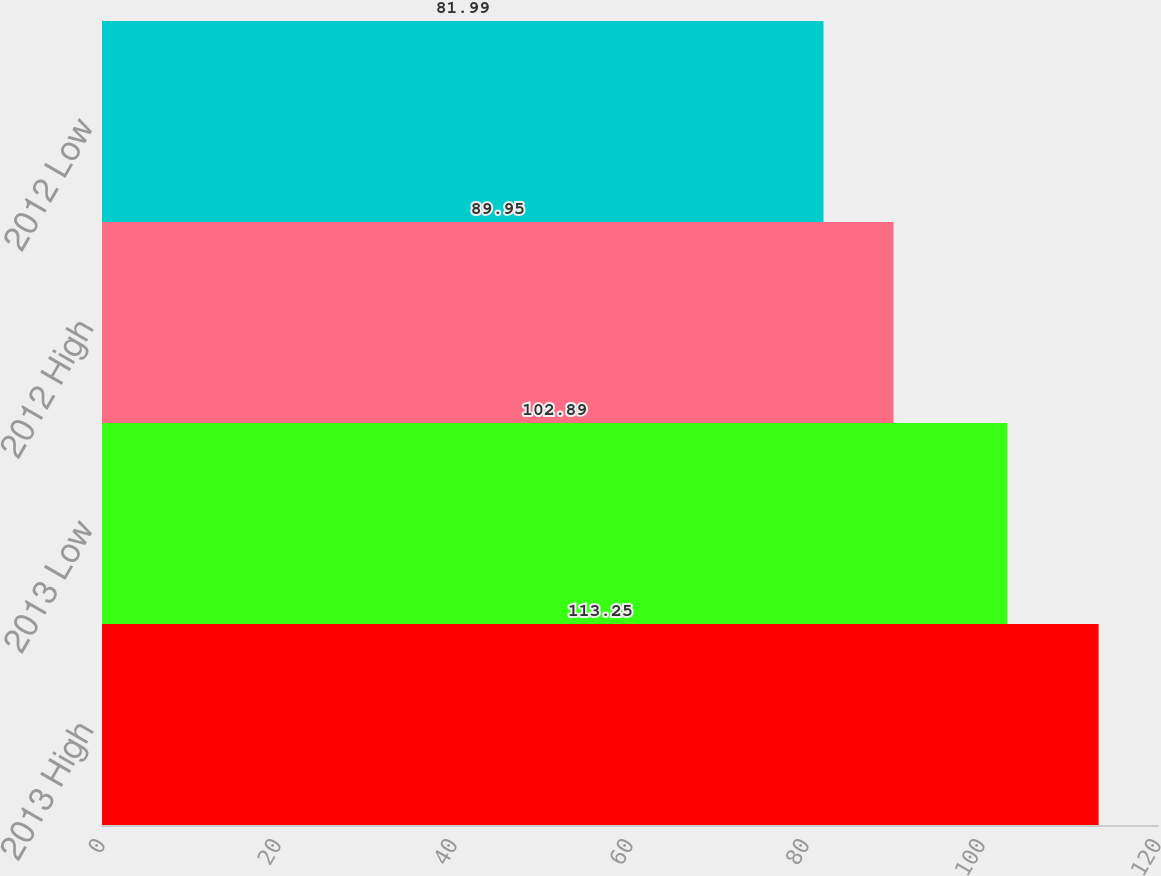<chart> <loc_0><loc_0><loc_500><loc_500><bar_chart><fcel>2013 High<fcel>2013 Low<fcel>2012 High<fcel>2012 Low<nl><fcel>113.25<fcel>102.89<fcel>89.95<fcel>81.99<nl></chart> 